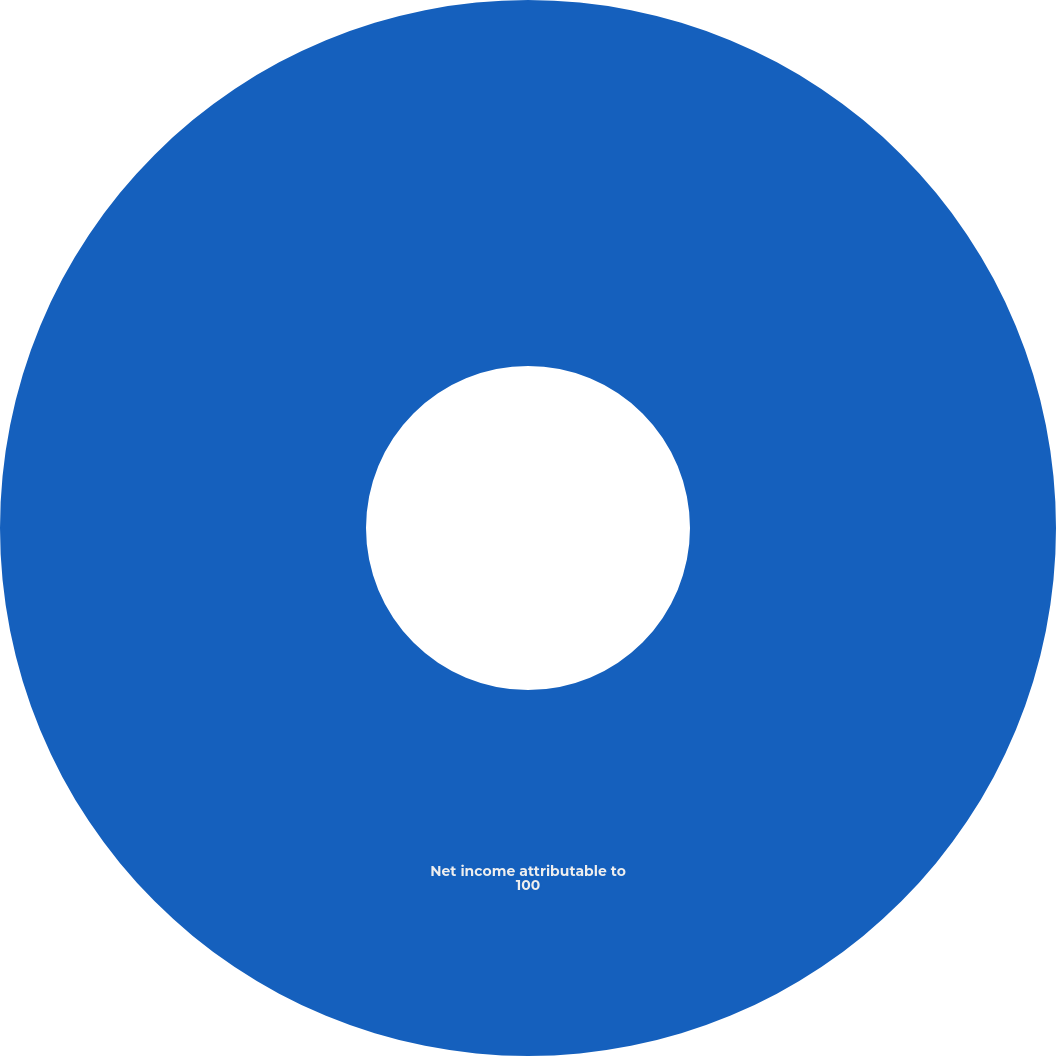<chart> <loc_0><loc_0><loc_500><loc_500><pie_chart><fcel>Net income attributable to<nl><fcel>100.0%<nl></chart> 